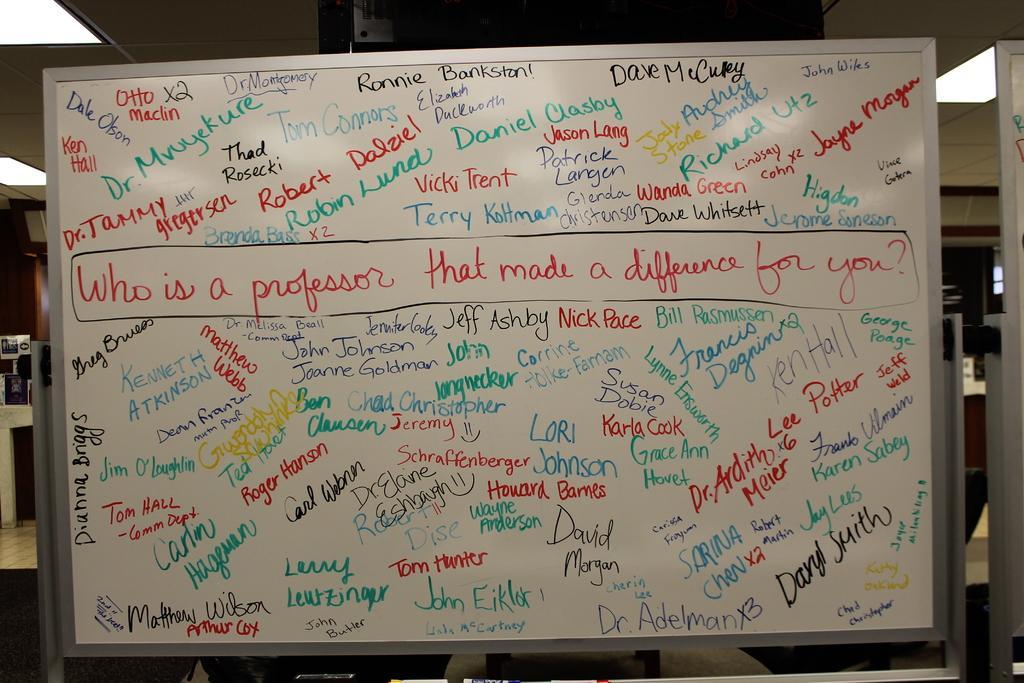Please provide a concise description of this image. In this image there is some text written on the board and the ceiling. 